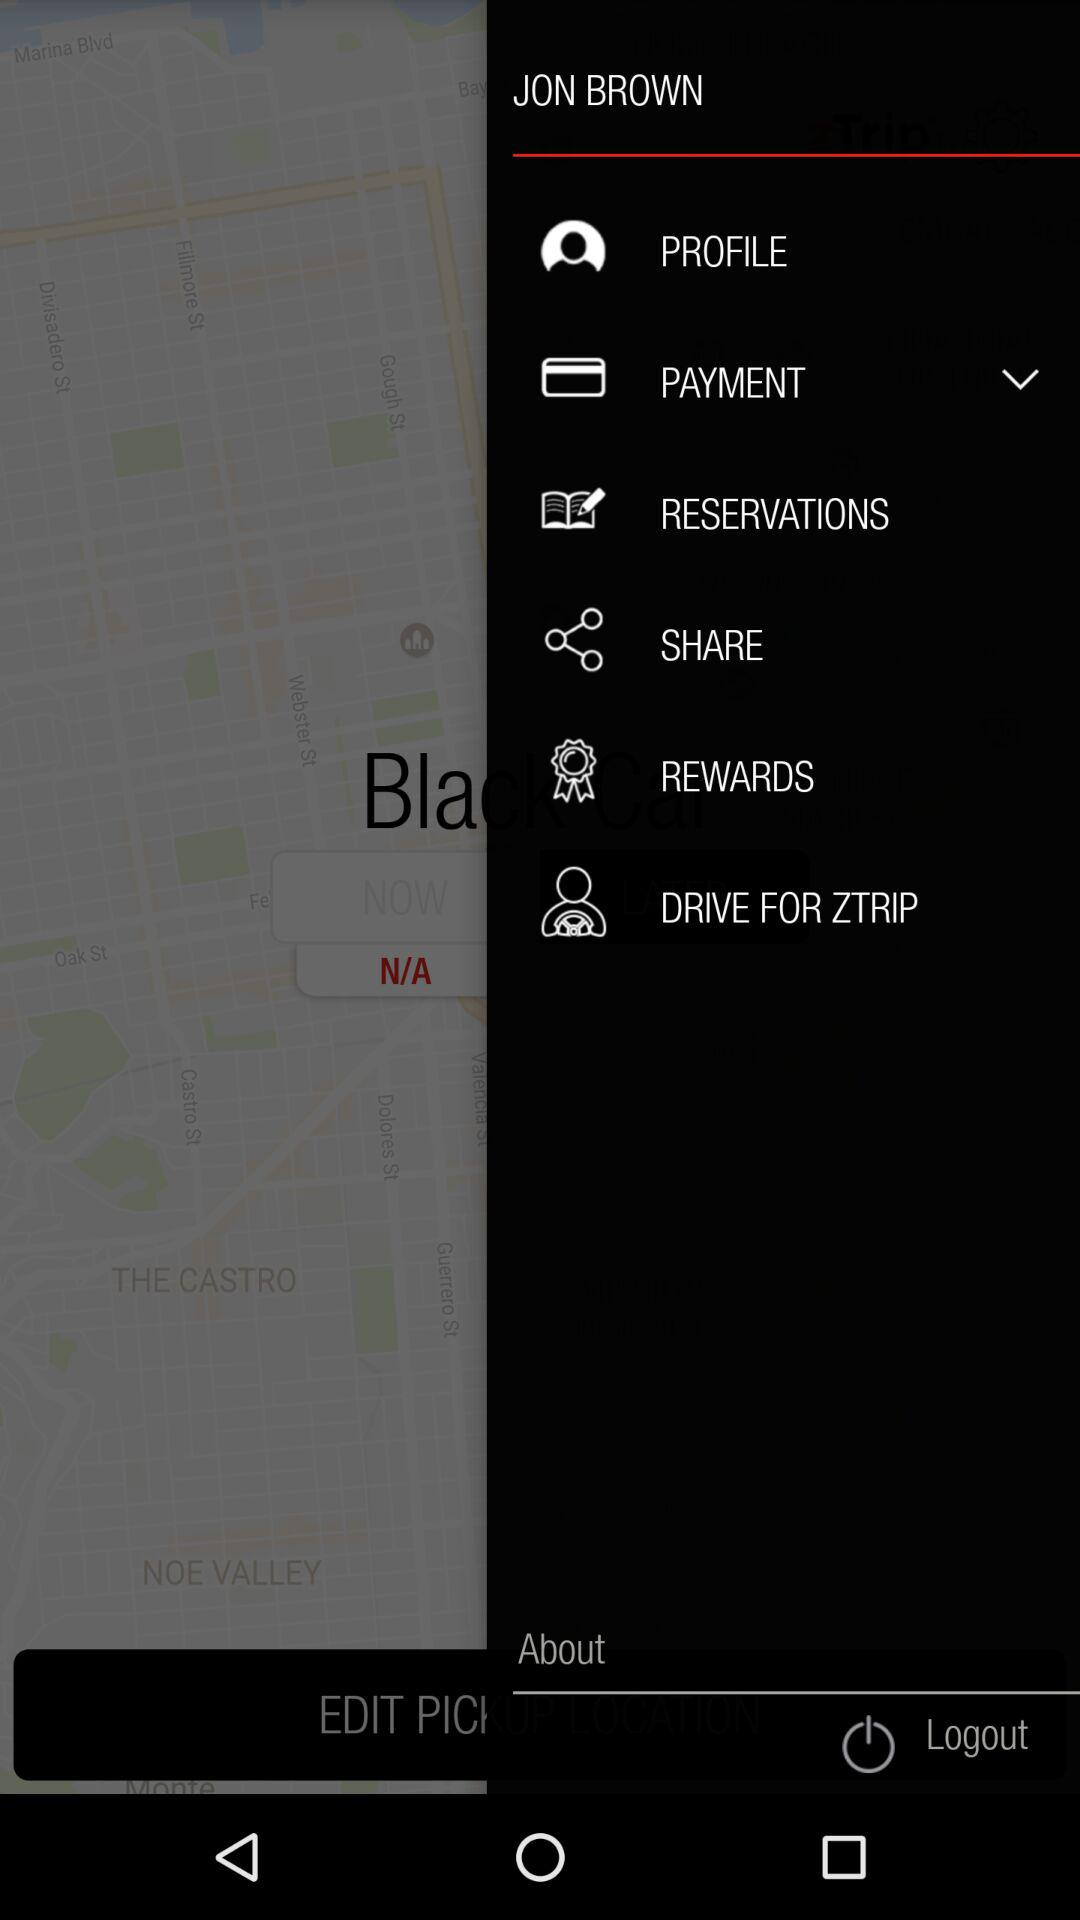What is the user name? The user name is Jon Brown. 